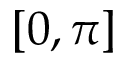Convert formula to latex. <formula><loc_0><loc_0><loc_500><loc_500>[ 0 , \pi ]</formula> 